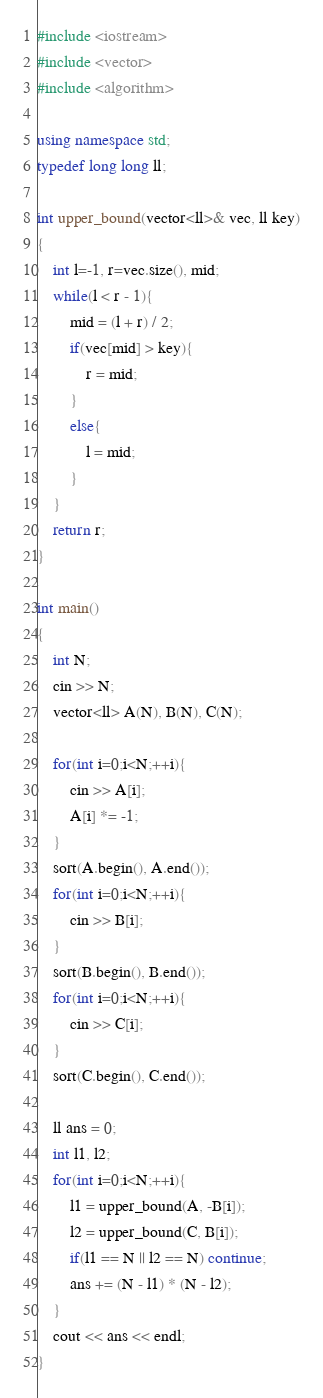Convert code to text. <code><loc_0><loc_0><loc_500><loc_500><_C++_>#include <iostream>
#include <vector>
#include <algorithm>

using namespace std;
typedef long long ll;

int upper_bound(vector<ll>& vec, ll key)
{
    int l=-1, r=vec.size(), mid;
    while(l < r - 1){
        mid = (l + r) / 2;
        if(vec[mid] > key){
            r = mid;
        }
        else{
            l = mid;
        }
    }
    return r;
}

int main()
{
    int N;
    cin >> N;
    vector<ll> A(N), B(N), C(N);
    
    for(int i=0;i<N;++i){
        cin >> A[i];
        A[i] *= -1;
    }
    sort(A.begin(), A.end());
    for(int i=0;i<N;++i){
        cin >> B[i];
    }
    sort(B.begin(), B.end());
    for(int i=0;i<N;++i){
        cin >> C[i];
    }
    sort(C.begin(), C.end());

    ll ans = 0;
    int l1, l2;
    for(int i=0;i<N;++i){
        l1 = upper_bound(A, -B[i]);
        l2 = upper_bound(C, B[i]);
        if(l1 == N || l2 == N) continue;
        ans += (N - l1) * (N - l2);
    }
    cout << ans << endl;
}
</code> 